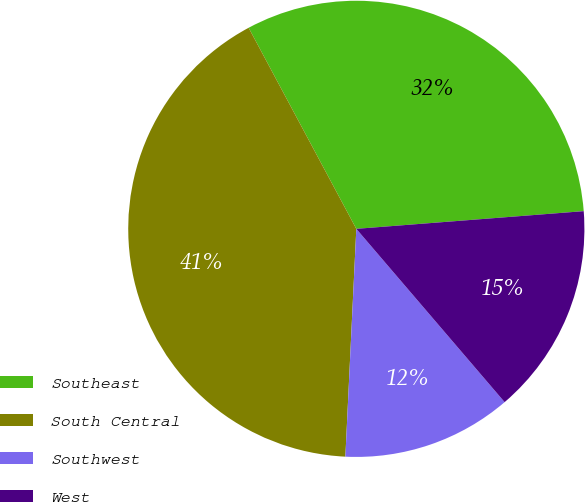Convert chart. <chart><loc_0><loc_0><loc_500><loc_500><pie_chart><fcel>Southeast<fcel>South Central<fcel>Southwest<fcel>West<nl><fcel>31.59%<fcel>41.41%<fcel>12.03%<fcel>14.97%<nl></chart> 